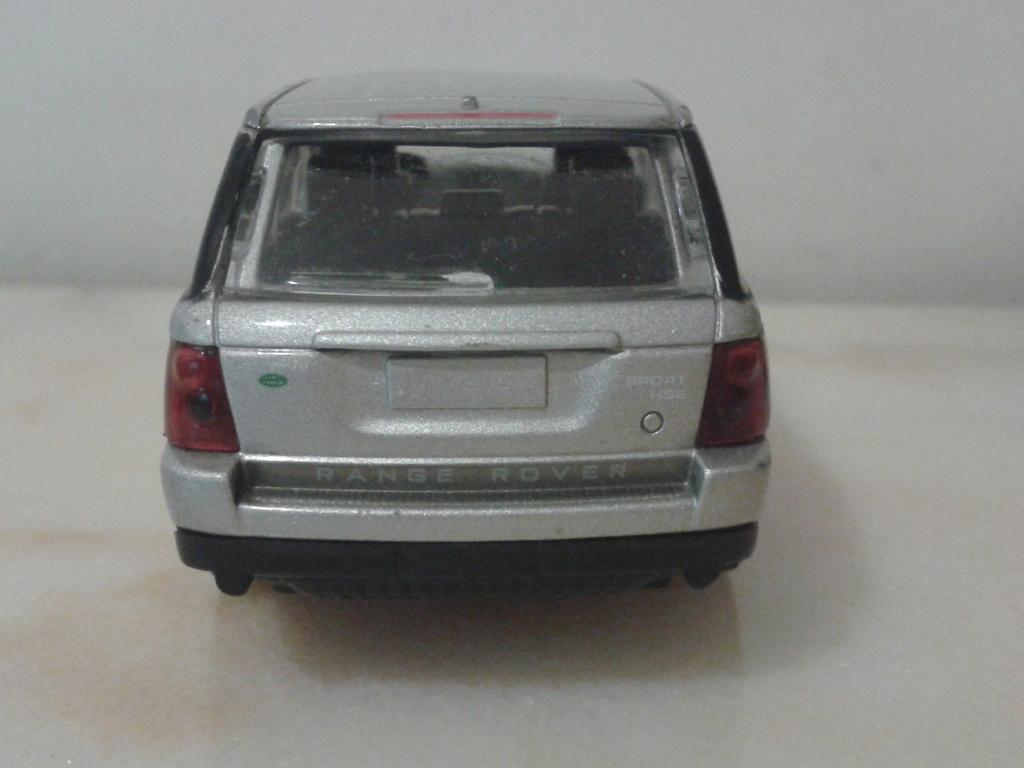What is the main subject of the image? The main subject of the image is a car. Can you describe the car's appearance? The car is silver in color. What type of ornament is hanging from the car's rearview mirror in the image? There is no information about an ornament hanging from the car's rearview mirror in the image. Does the car's existence in the image prove the existence of parallel universes? The car's existence in the image does not prove the existence of parallel universes, as the image only shows a car and its color. 